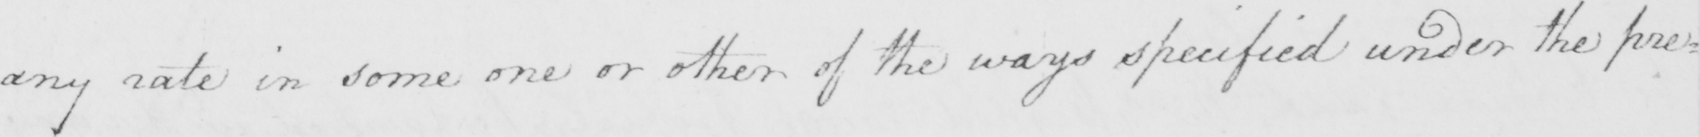What does this handwritten line say? any rate in some one or other of the ways specified under the pre= 